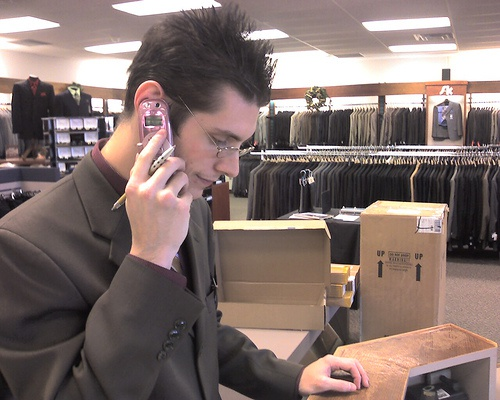Describe the objects in this image and their specific colors. I can see people in gray, black, and lightpink tones, cell phone in gray, lightpink, and darkgray tones, tie in gray and black tones, tie in gray, darkgray, lavender, violet, and pink tones, and tie in gray, maroon, brown, and black tones in this image. 